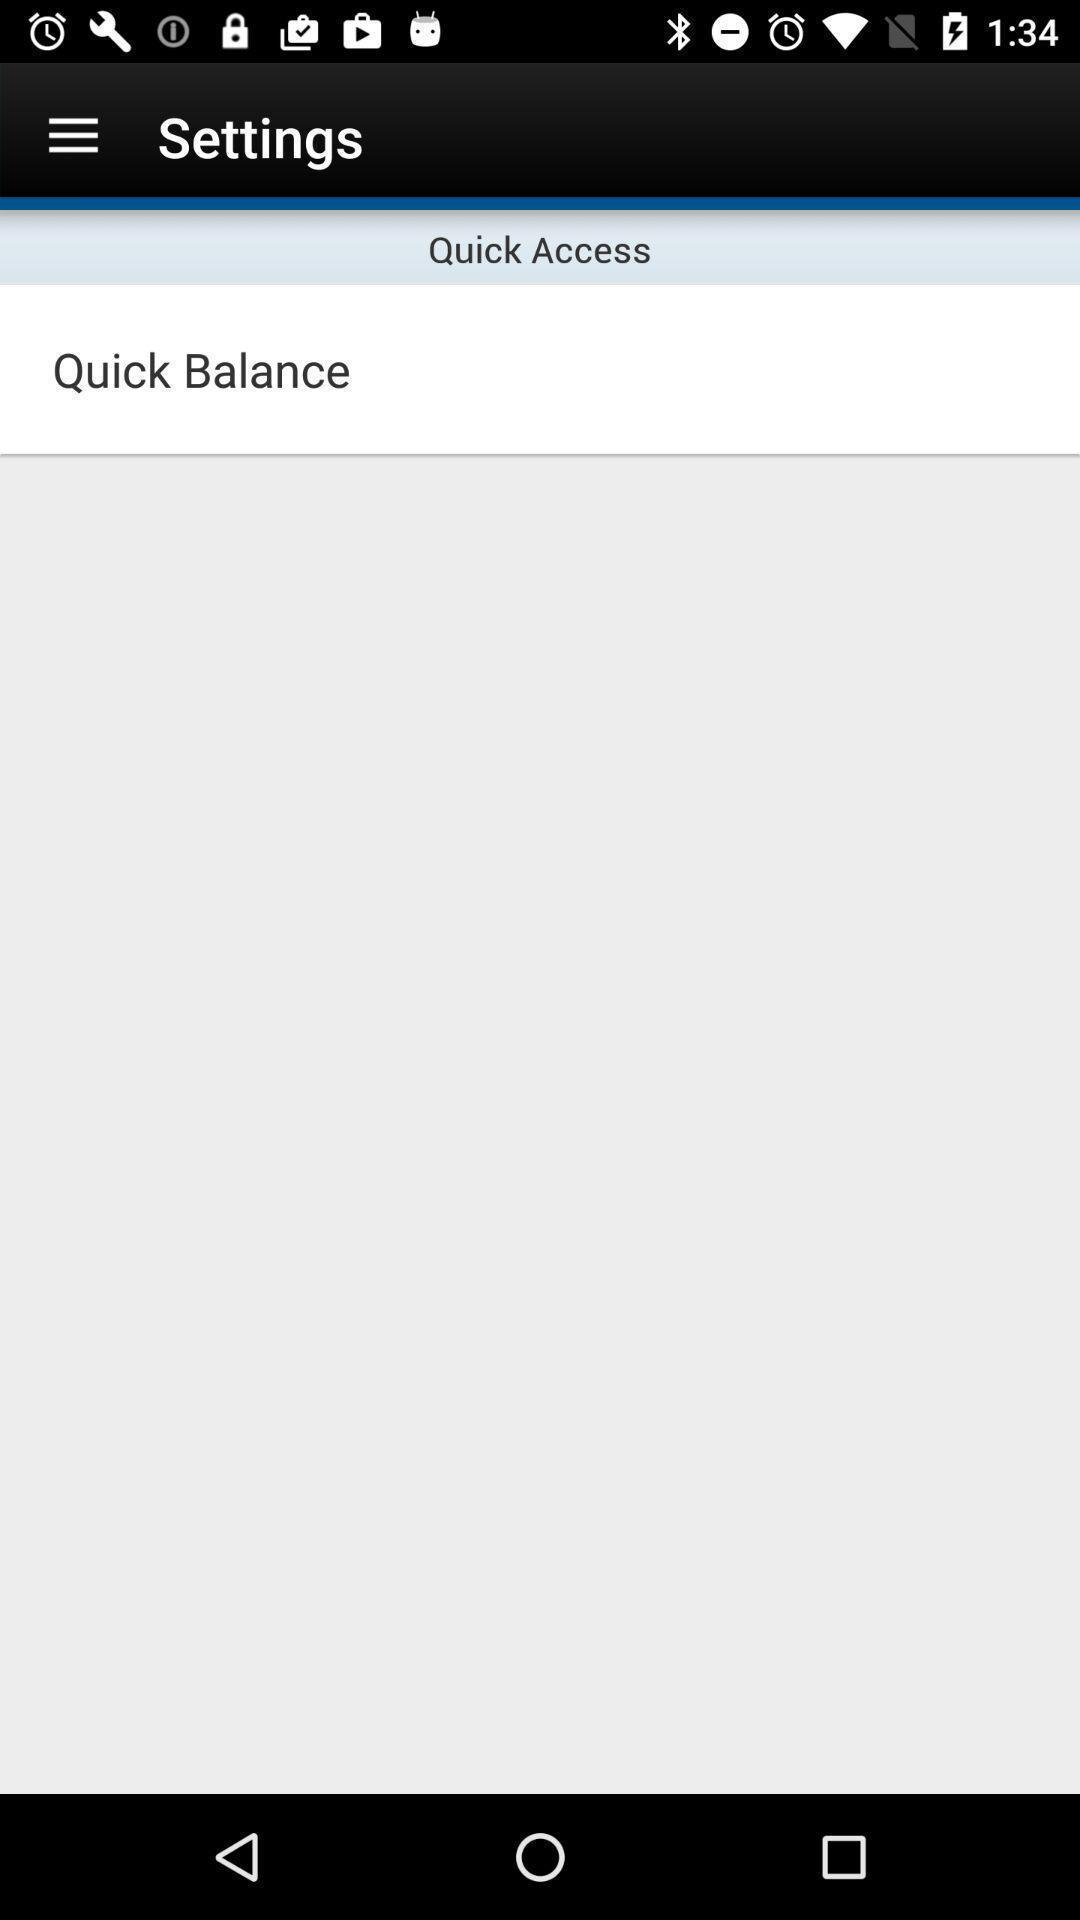Explain what's happening in this screen capture. Settings page showing. 